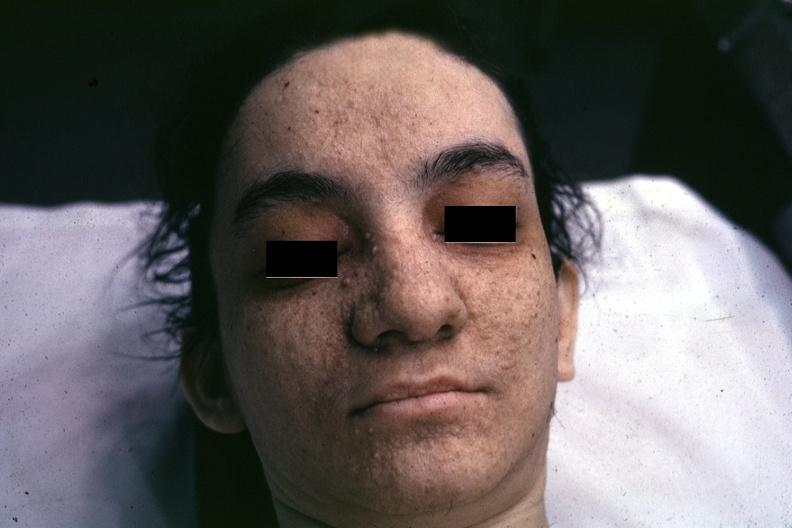what does this image show?
Answer the question using a single word or phrase. Very good example associated with tuberous sclerosis 